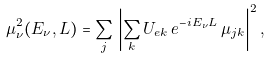<formula> <loc_0><loc_0><loc_500><loc_500>\mu _ { \nu } ^ { 2 } ( E _ { \nu } , L ) = \sum _ { j } \, \left | \sum _ { k } U _ { e k } \, e ^ { - i E _ { \nu } L } \, \mu _ { j k } \right | ^ { 2 } ,</formula> 